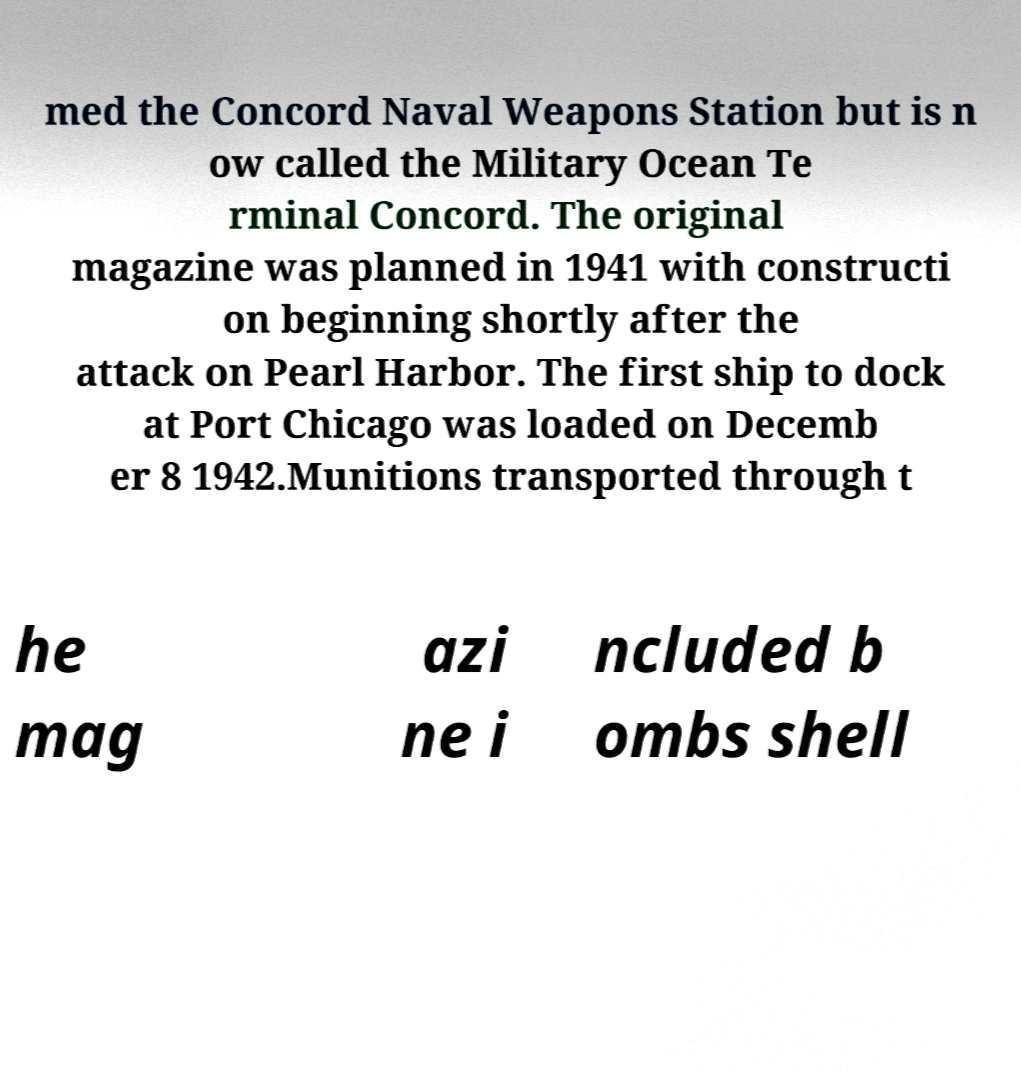There's text embedded in this image that I need extracted. Can you transcribe it verbatim? med the Concord Naval Weapons Station but is n ow called the Military Ocean Te rminal Concord. The original magazine was planned in 1941 with constructi on beginning shortly after the attack on Pearl Harbor. The first ship to dock at Port Chicago was loaded on Decemb er 8 1942.Munitions transported through t he mag azi ne i ncluded b ombs shell 